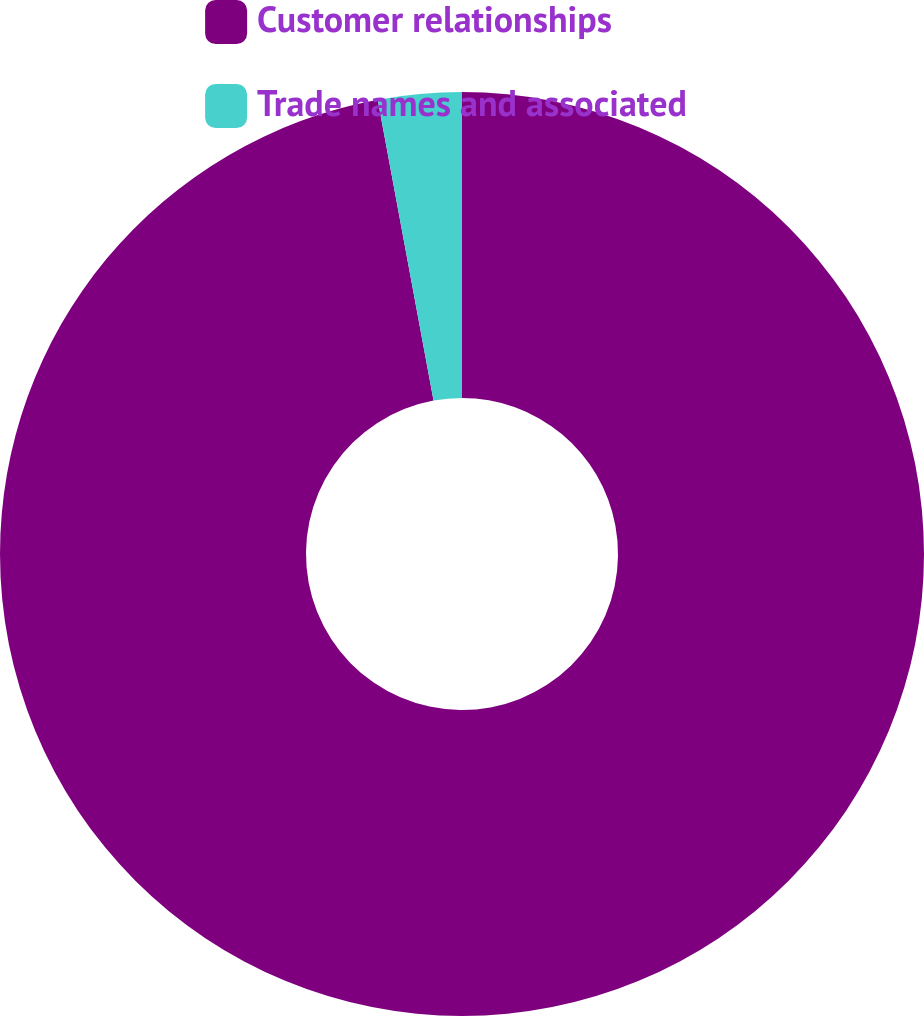<chart> <loc_0><loc_0><loc_500><loc_500><pie_chart><fcel>Customer relationships<fcel>Trade names and associated<nl><fcel>97.08%<fcel>2.92%<nl></chart> 